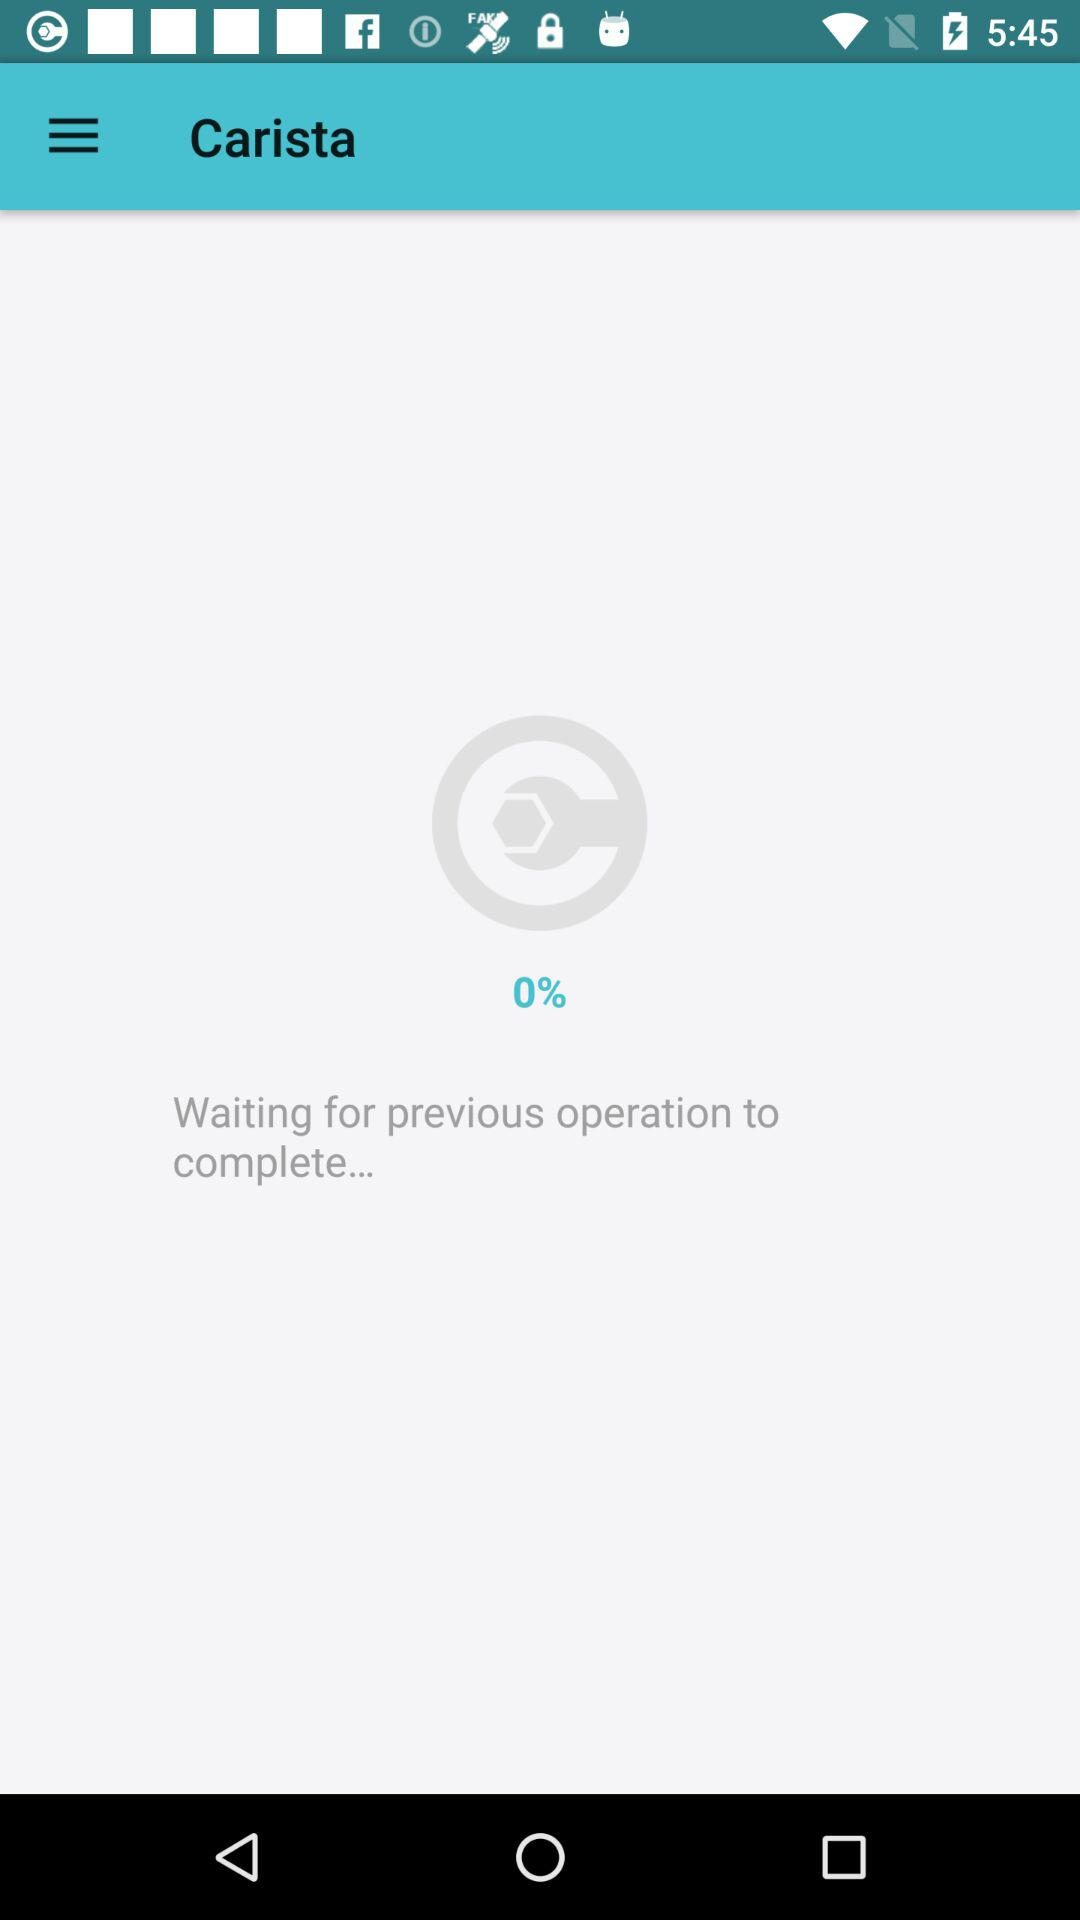What is the version of this application?
When the provided information is insufficient, respond with <no answer>. <no answer> 